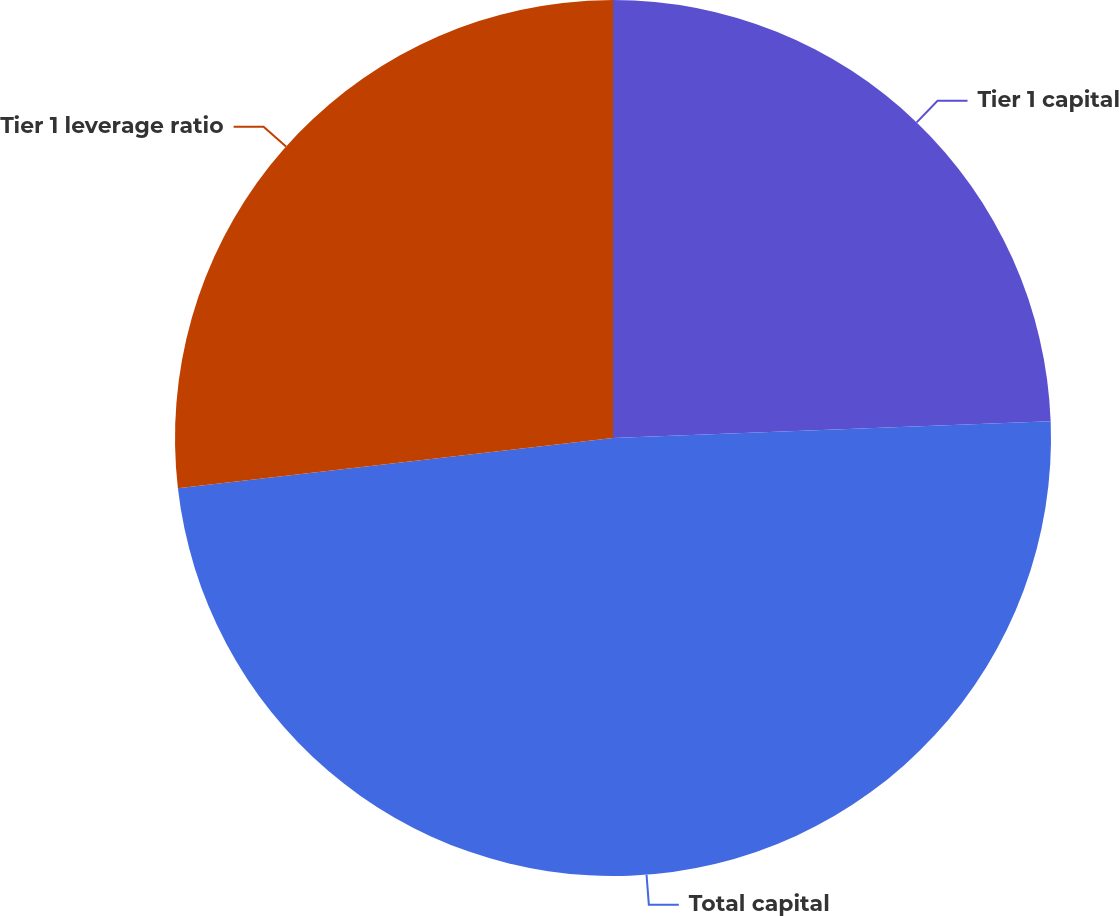<chart> <loc_0><loc_0><loc_500><loc_500><pie_chart><fcel>Tier 1 capital<fcel>Total capital<fcel>Tier 1 leverage ratio<nl><fcel>24.39%<fcel>48.78%<fcel>26.83%<nl></chart> 